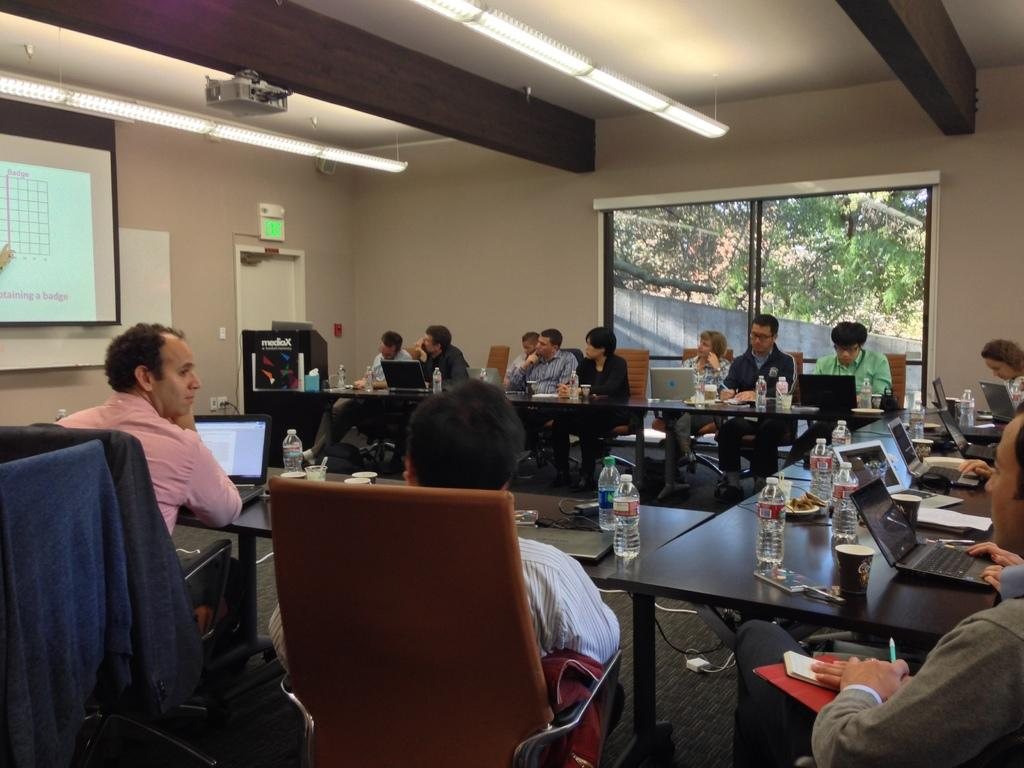What are the people in the image doing? The people in the image are sitting on chairs. What objects are on the tables in the image? There are laptops, bottles, and cups on the tables in the image. What is the purpose of the projector's screen in the image? The projector's screen is likely used for displaying information or presentations. Can you tell me how many giraffes are present in the image? There are no giraffes present in the image. What type of pan is being used by the people in the image? There is no pan visible in the image; the people are using laptops and a projector's screen. 